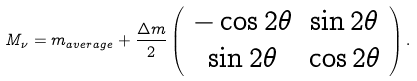Convert formula to latex. <formula><loc_0><loc_0><loc_500><loc_500>M _ { \nu } = m _ { a v e r a g e } + \frac { \Delta m } { 2 } \left ( \begin{array} { c c } { - \cos 2 \theta } & { \sin 2 \theta } \\ { \sin 2 \theta } & { \cos 2 \theta } \end{array} \right ) .</formula> 